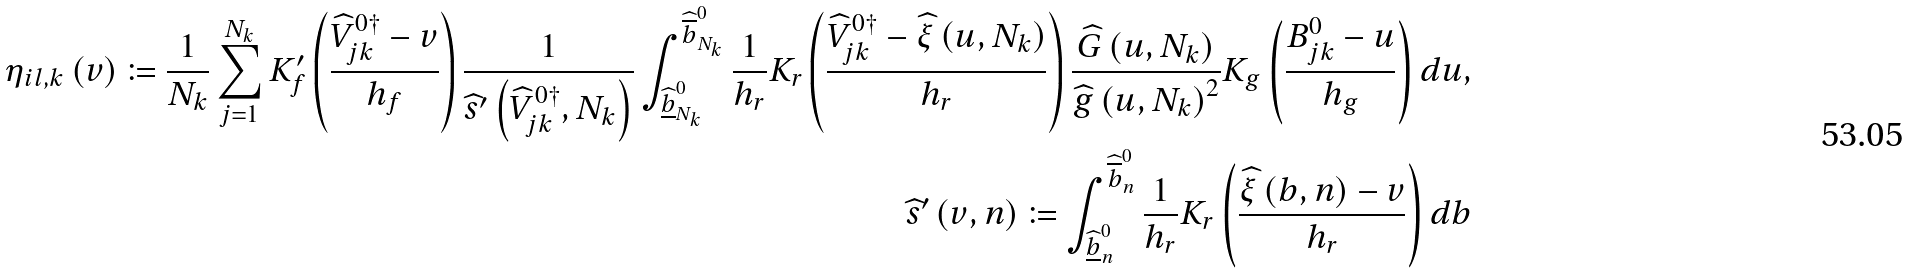<formula> <loc_0><loc_0><loc_500><loc_500>\eta _ { i l , k } \left ( v \right ) \coloneqq \frac { 1 } { N _ { k } } \sum _ { j = 1 } ^ { N _ { k } } K _ { f } ^ { \prime } \left ( \frac { \widehat { V } _ { j k } ^ { 0 \dagger } - v } { h _ { f } } \right ) \frac { 1 } { \widehat { s } ^ { \prime } \left ( \widehat { V } _ { j k } ^ { 0 \dagger } , N _ { k } \right ) } \int _ { \widehat { \underline { b } } _ { N _ { k } } ^ { 0 } } ^ { \widehat { \overline { b } } _ { N _ { k } } ^ { 0 } } \frac { 1 } { h _ { r } } K _ { r } \left ( \frac { \widehat { V } _ { j k } ^ { 0 \dagger } - \widehat { \xi } \left ( u , N _ { k } \right ) } { h _ { r } } \right ) \frac { \widehat { G } \left ( u , N _ { k } \right ) } { \widehat { g } \left ( u , N _ { k } \right ) ^ { 2 } } K _ { g } \left ( \frac { B _ { j k } ^ { 0 } - u } { h _ { g } } \right ) d u , \\ \widehat { s } ^ { \prime } \left ( v , n \right ) \coloneqq \int _ { \widehat { \underline { b } } _ { n } ^ { 0 } } ^ { \widehat { \overline { b } } _ { n } ^ { 0 } } \frac { 1 } { h _ { r } } K _ { r } \left ( \frac { \widehat { \xi } \left ( b , n \right ) - v } { h _ { r } } \right ) d b</formula> 